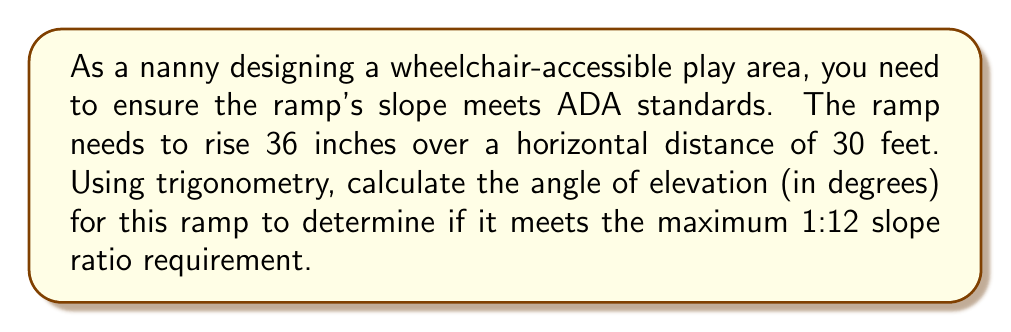Show me your answer to this math problem. Let's approach this step-by-step:

1) First, we need to understand what the given information represents:
   - Rise (vertical distance) = 36 inches
   - Run (horizontal distance) = 30 feet = 360 inches (since 1 foot = 12 inches)

2) The slope of a ramp is typically expressed as a ratio of rise to run. The ADA standard of 1:12 means for every 1 inch of rise, there should be 12 inches of run.

3) To find the angle of elevation, we can use the tangent function:

   $$\tan(\theta) = \frac{\text{opposite}}{\text{adjacent}} = \frac{\text{rise}}{\text{run}}$$

4) Plugging in our values:

   $$\tan(\theta) = \frac{36}{360} = \frac{1}{10} = 0.1$$

5) To find the angle $\theta$, we need to use the inverse tangent (arctan) function:

   $$\theta = \arctan(0.1)$$

6) Using a calculator or trigonometric tables:

   $$\theta \approx 5.71^\circ$$

7) To check if this meets the ADA requirement:
   - The 1:12 ratio is equivalent to $\arctan(\frac{1}{12}) \approx 4.76^\circ$
   - Our ramp angle (5.71°) is greater than 4.76°, so it doesn't meet the requirement

8) To meet the requirement, the run would need to be longer or the rise shorter.
Answer: $5.71^\circ$ (does not meet ADA requirement) 